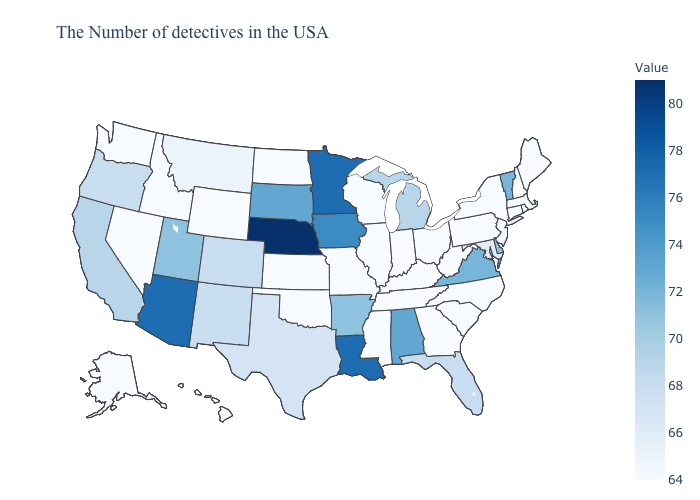Which states hav the highest value in the Northeast?
Quick response, please. Vermont. Which states have the lowest value in the Northeast?
Concise answer only. Maine, Massachusetts, Rhode Island, New Hampshire, Connecticut, New York, New Jersey, Pennsylvania. Which states hav the highest value in the Northeast?
Quick response, please. Vermont. 